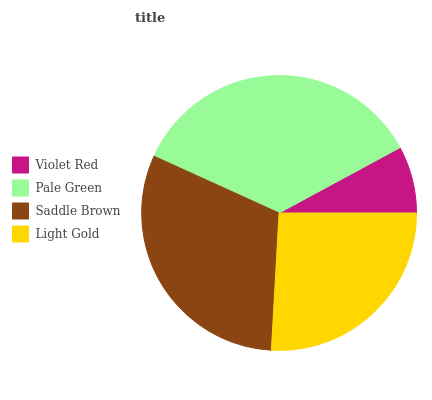Is Violet Red the minimum?
Answer yes or no. Yes. Is Pale Green the maximum?
Answer yes or no. Yes. Is Saddle Brown the minimum?
Answer yes or no. No. Is Saddle Brown the maximum?
Answer yes or no. No. Is Pale Green greater than Saddle Brown?
Answer yes or no. Yes. Is Saddle Brown less than Pale Green?
Answer yes or no. Yes. Is Saddle Brown greater than Pale Green?
Answer yes or no. No. Is Pale Green less than Saddle Brown?
Answer yes or no. No. Is Saddle Brown the high median?
Answer yes or no. Yes. Is Light Gold the low median?
Answer yes or no. Yes. Is Light Gold the high median?
Answer yes or no. No. Is Saddle Brown the low median?
Answer yes or no. No. 